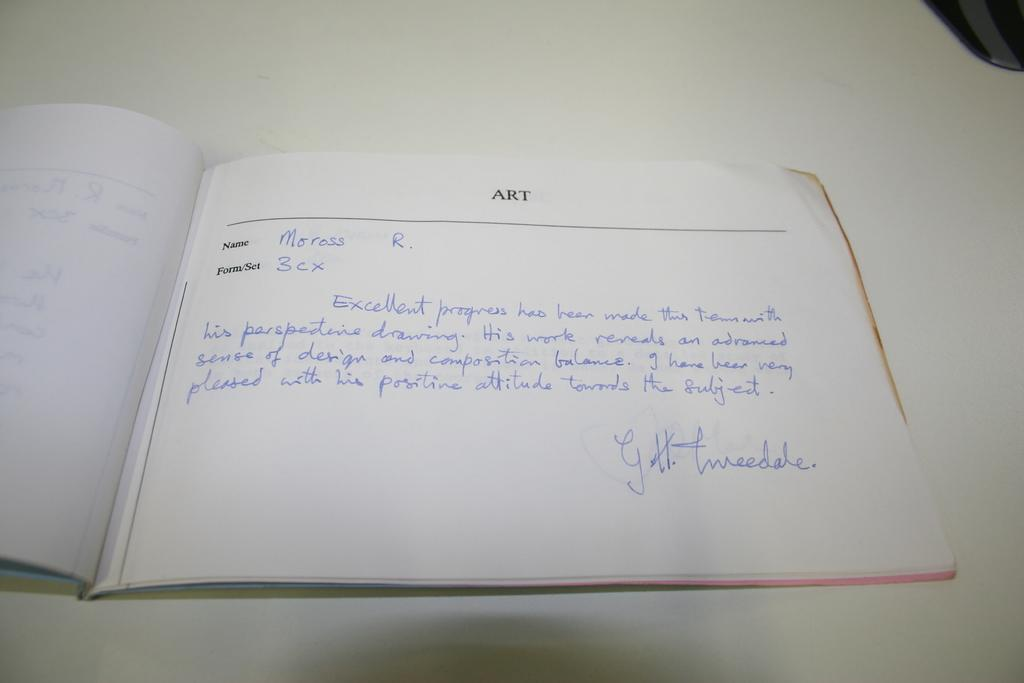<image>
Give a short and clear explanation of the subsequent image. A white notebook with handwritten on it titled Art 